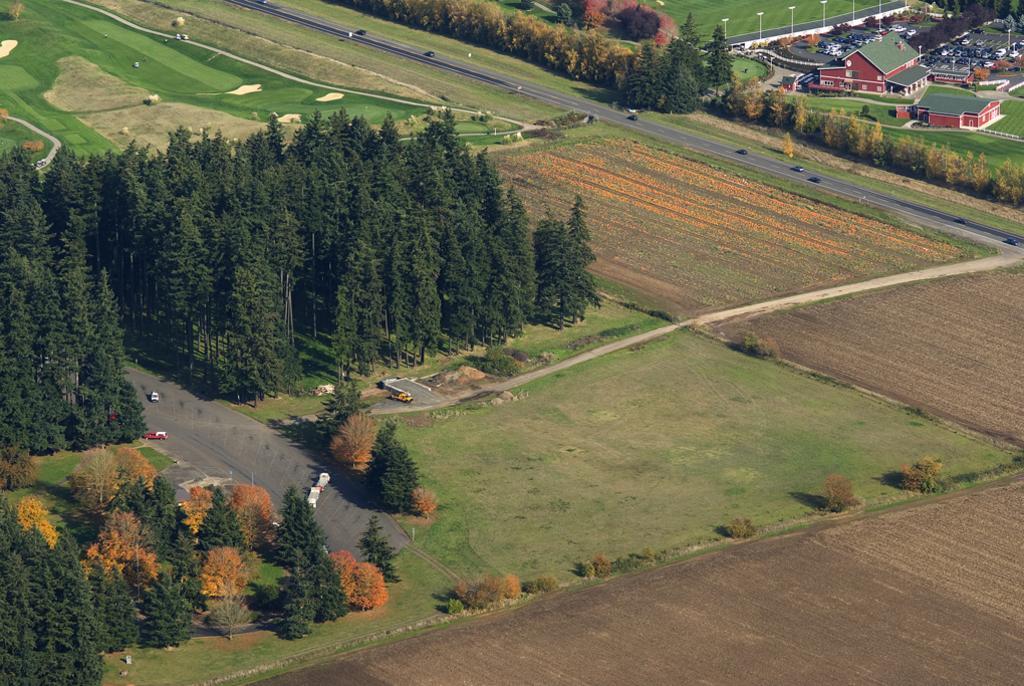Please provide a concise description of this image. This picture shows the aerial view. There are some cropping lands, so many different objects are on the surface, some roads are there, some vehicles are parked and some vehicles are on the road. There are so many trees, plants, bushes and grass on the ground. There are some houses, some poles and some street lights near to the houses. 